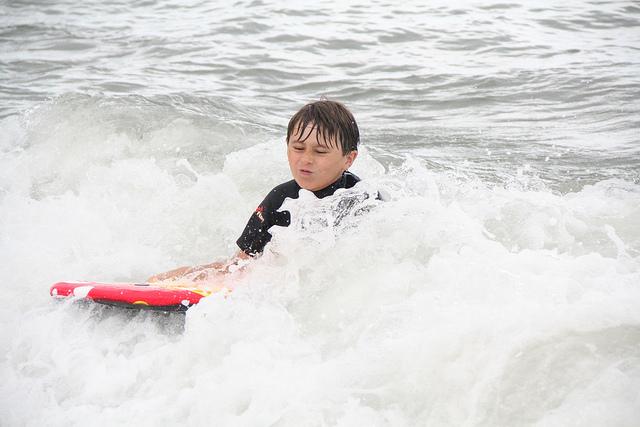Is the water calm?
Quick response, please. No. Is the ocean shallow?
Give a very brief answer. Yes. What color is the board?
Quick response, please. Red. Is the kid having fun?
Concise answer only. No. 